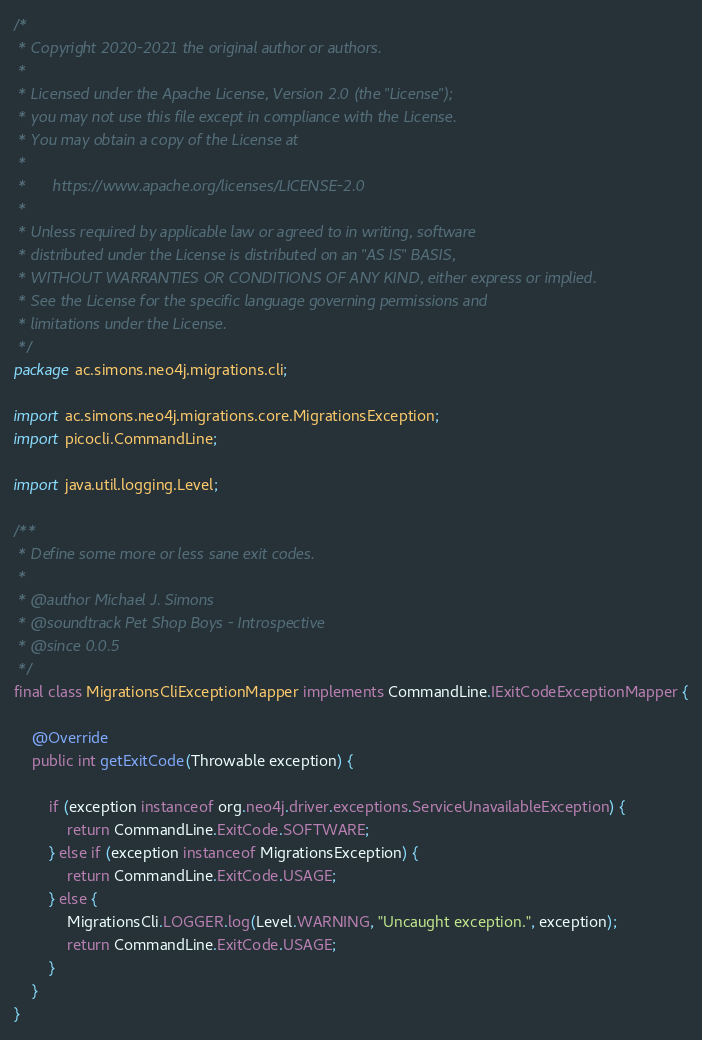<code> <loc_0><loc_0><loc_500><loc_500><_Java_>/*
 * Copyright 2020-2021 the original author or authors.
 *
 * Licensed under the Apache License, Version 2.0 (the "License");
 * you may not use this file except in compliance with the License.
 * You may obtain a copy of the License at
 *
 *      https://www.apache.org/licenses/LICENSE-2.0
 *
 * Unless required by applicable law or agreed to in writing, software
 * distributed under the License is distributed on an "AS IS" BASIS,
 * WITHOUT WARRANTIES OR CONDITIONS OF ANY KIND, either express or implied.
 * See the License for the specific language governing permissions and
 * limitations under the License.
 */
package ac.simons.neo4j.migrations.cli;

import ac.simons.neo4j.migrations.core.MigrationsException;
import picocli.CommandLine;

import java.util.logging.Level;

/**
 * Define some more or less sane exit codes.
 *
 * @author Michael J. Simons
 * @soundtrack Pet Shop Boys - Introspective
 * @since 0.0.5
 */
final class MigrationsCliExceptionMapper implements CommandLine.IExitCodeExceptionMapper {

	@Override
	public int getExitCode(Throwable exception) {

		if (exception instanceof org.neo4j.driver.exceptions.ServiceUnavailableException) {
			return CommandLine.ExitCode.SOFTWARE;
		} else if (exception instanceof MigrationsException) {
			return CommandLine.ExitCode.USAGE;
		} else {
			MigrationsCli.LOGGER.log(Level.WARNING, "Uncaught exception.", exception);
			return CommandLine.ExitCode.USAGE;
		}
	}
}
</code> 